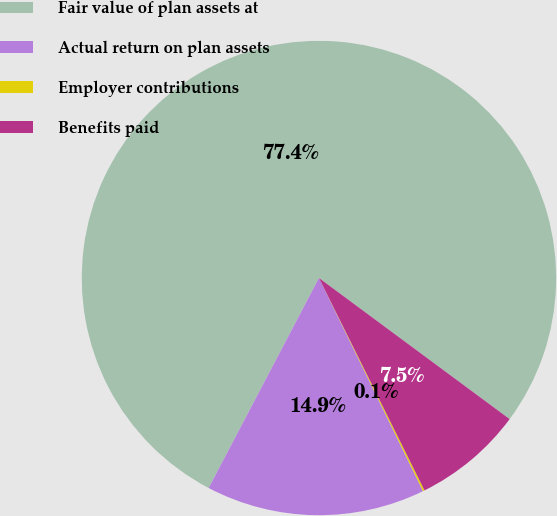Convert chart to OTSL. <chart><loc_0><loc_0><loc_500><loc_500><pie_chart><fcel>Fair value of plan assets at<fcel>Actual return on plan assets<fcel>Employer contributions<fcel>Benefits paid<nl><fcel>77.44%<fcel>14.93%<fcel>0.11%<fcel>7.52%<nl></chart> 